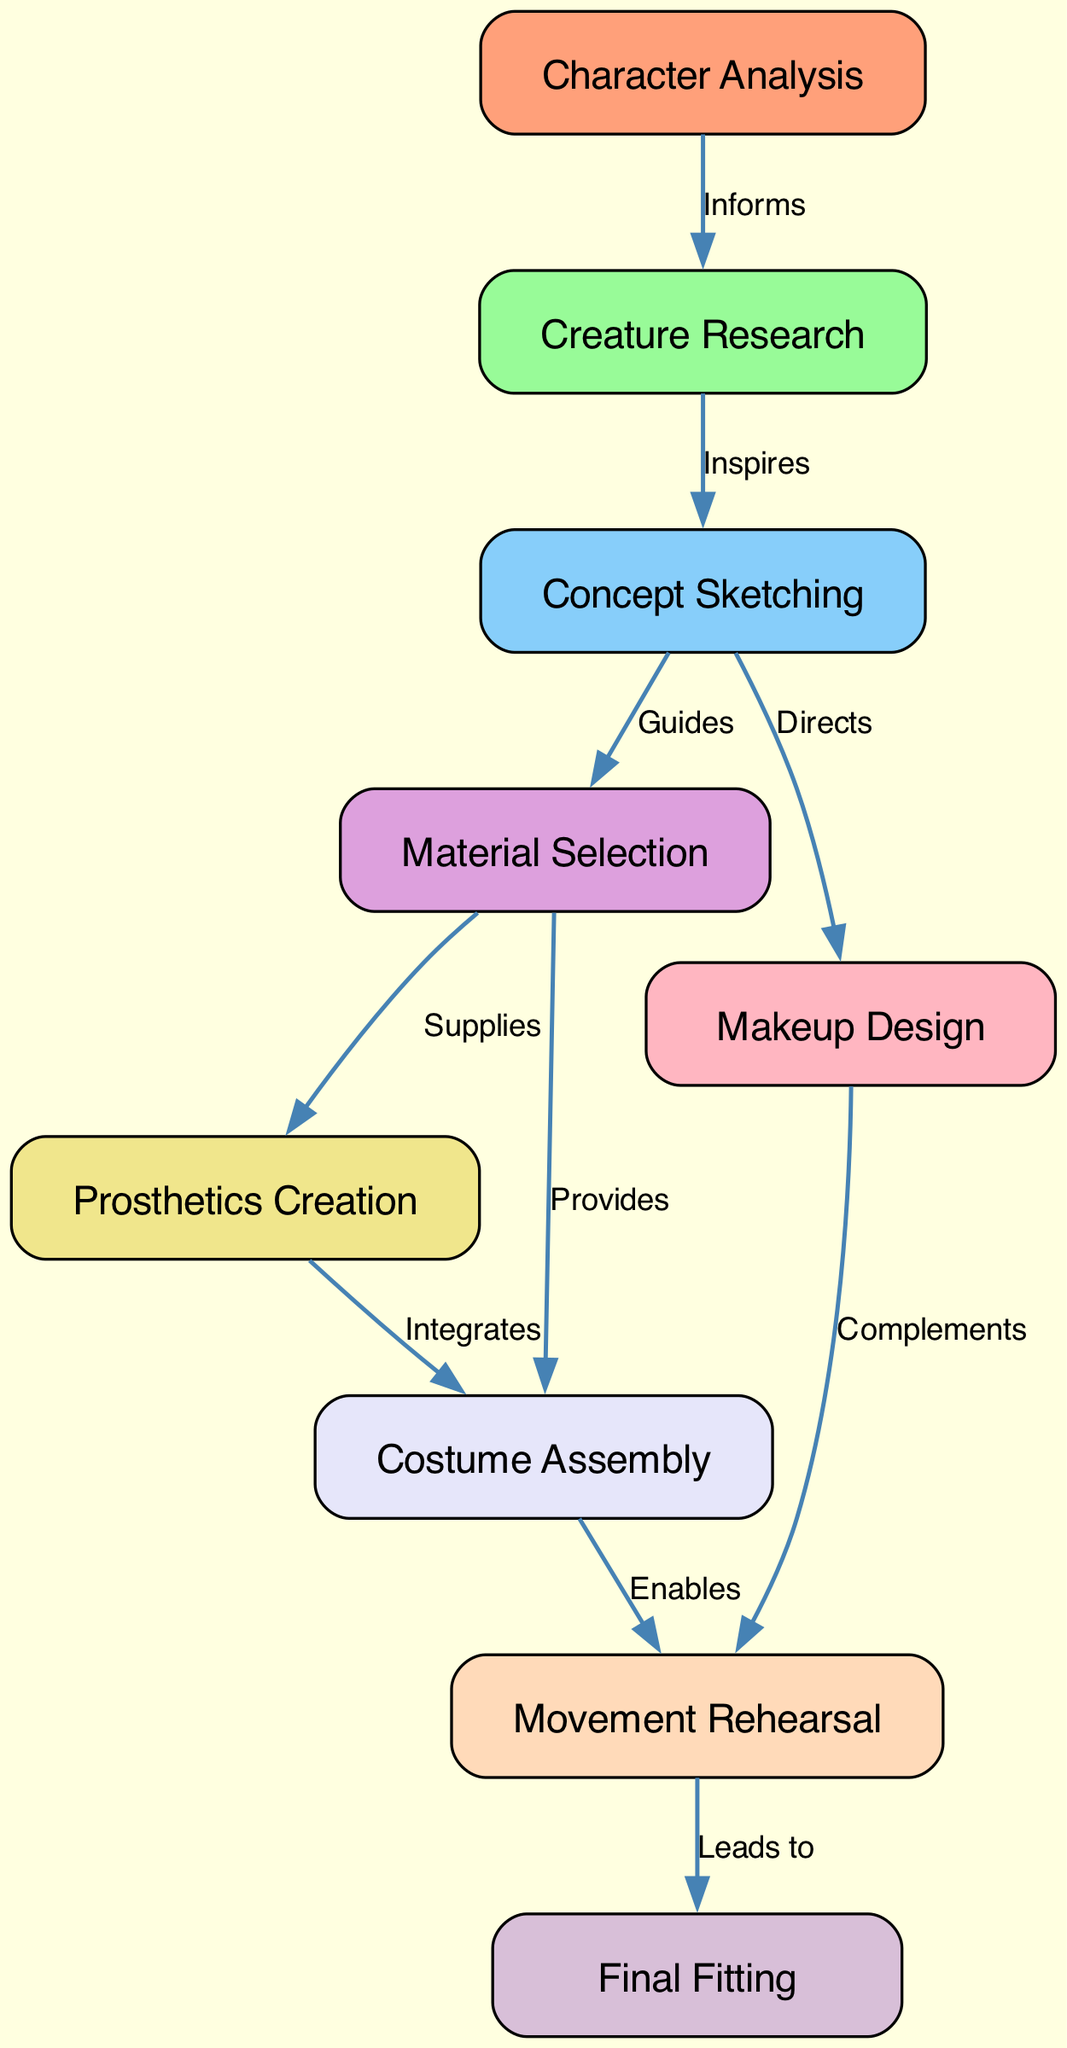What is the first step in the costume design process? The diagram indicates that the first step is 'Character Analysis', as it is the first node listed.
Answer: Character Analysis How many nodes are in the diagram? Counting the nodes listed in the data section reveals there are a total of nine nodes present in the diagram.
Answer: Nine What does 'Creature Research' inspire? The flow from 'Creature Research' to 'Concept Sketching' in the edges shows that 'Creature Research' inspires 'Concept Sketching'.
Answer: Concept Sketching Which step integrates with 'Prosthetics Creation'? The edge from 'Material Selection' to 'Prosthetics Creation' establishes that 'Material Selection' supplies the resources necessary for 'Prosthetics Creation', demonstrating their integration.
Answer: Material Selection What leads to the 'Final Fitting'? The progression from 'Movement Rehearsal' to 'Final Fitting' indicates that 'Movement Rehearsal' leads to 'Final Fitting'.
Answer: Movement Rehearsal How many edges are present in the diagram? By examining the edges listed in the data section, it can be determined that there are a total of ten edges connecting the nodes.
Answer: Ten What role does 'Makeup Design' play in the rehearsal process? The edge connecting 'Makeup Design' to 'Movement Rehearsal' indicates that 'Makeup Design' complements 'Movement Rehearsal', showing its supportive role.
Answer: Complements Which node provides materials for both 'Prosthetics Creation' and 'Costume Assembly'? The node 'Material Selection' is linked to both 'Prosthetics Creation' and 'Costume Assembly', showing it provides for both.
Answer: Material Selection What does the process flow from 'Concept Sketching' to 'Material Selection' illustrate? The flow from 'Concept Sketching' to 'Material Selection' signifies that 'Concept Sketching' guides the choice of materials needed for the costume.
Answer: Guides 